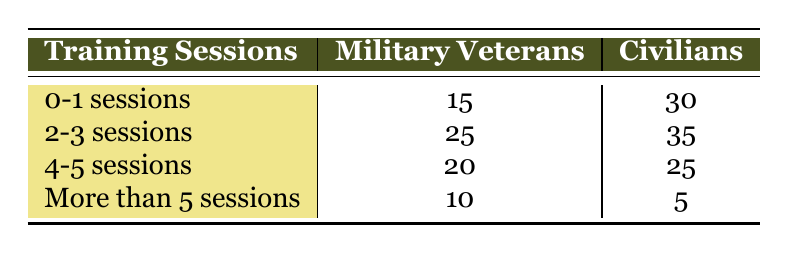What is the total number of military veterans who attended 0-1 sessions? According to the table, 15 military veterans attended 0-1 sessions.
Answer: 15 How many civilians attended more than 5 sessions? The table indicates that 5 civilians attended more than 5 sessions.
Answer: 5 What is the difference in attendance between military veterans and civilians for the 2-3 sessions category? For the 2-3 sessions, military veterans attended 25 sessions while civilians attended 35 sessions. The difference is 35 - 25 = 10.
Answer: 10 How many total training sessions did military veterans attend? To find the total attended by military veterans, sum the numbers: 15 + 25 + 20 + 10 = 70.
Answer: 70 Did more civilians attend the 4-5 sessions compared to military veterans? The table shows that 25 civilians attended 4-5 sessions, while 20 military veterans attended the same. So yes, more civilians attended.
Answer: Yes What percentage of military veterans attended more than 5 sessions? There are a total of 70 military veterans. The number who attended more than 5 sessions is 10. The percentage is (10/70) * 100 = 14.29%.
Answer: 14.29% What is the average number of training sessions attended by civilians? Add the total attendance: 30 + 35 + 25 + 5 = 95. There are 4 categories (0-1, 2-3, 4-5, more than 5 sessions). So, the average is 95 / 4 = 23.75.
Answer: 23.75 In which category did military veterans have the highest attendance? Looking at the table, military veterans had the highest attendance in the 2-3 sessions category with 25 attendees.
Answer: 2-3 sessions Which group had a higher attendance in the category of 4-5 sessions? Military veterans had 20 attendees and civilians had 25 attendees in the 4-5 sessions category. Since 25 > 20, civilians had a higher attendance.
Answer: Civilians 